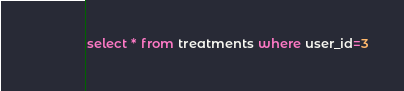Convert code to text. <code><loc_0><loc_0><loc_500><loc_500><_SQL_>select * from treatments where user_id=3</code> 